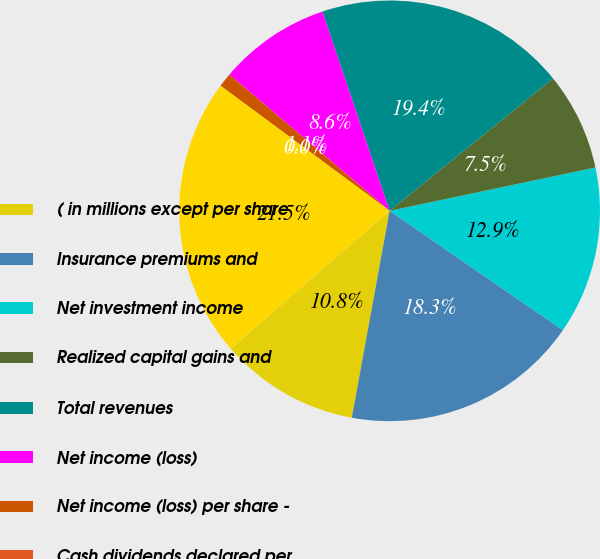Convert chart. <chart><loc_0><loc_0><loc_500><loc_500><pie_chart><fcel>( in millions except per share<fcel>Insurance premiums and<fcel>Net investment income<fcel>Realized capital gains and<fcel>Total revenues<fcel>Net income (loss)<fcel>Net income (loss) per share -<fcel>Cash dividends declared per<fcel>Investments<nl><fcel>10.75%<fcel>18.28%<fcel>12.9%<fcel>7.53%<fcel>19.35%<fcel>8.6%<fcel>1.08%<fcel>0.0%<fcel>21.51%<nl></chart> 